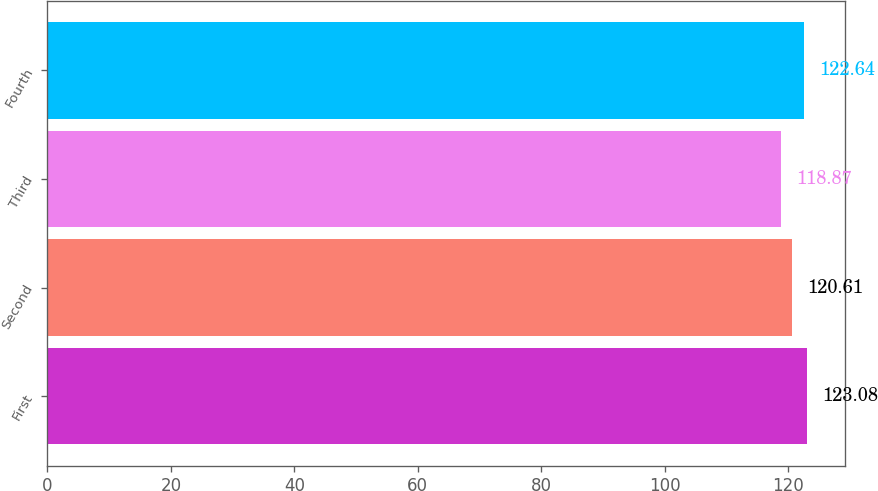Convert chart. <chart><loc_0><loc_0><loc_500><loc_500><bar_chart><fcel>First<fcel>Second<fcel>Third<fcel>Fourth<nl><fcel>123.08<fcel>120.61<fcel>118.87<fcel>122.64<nl></chart> 